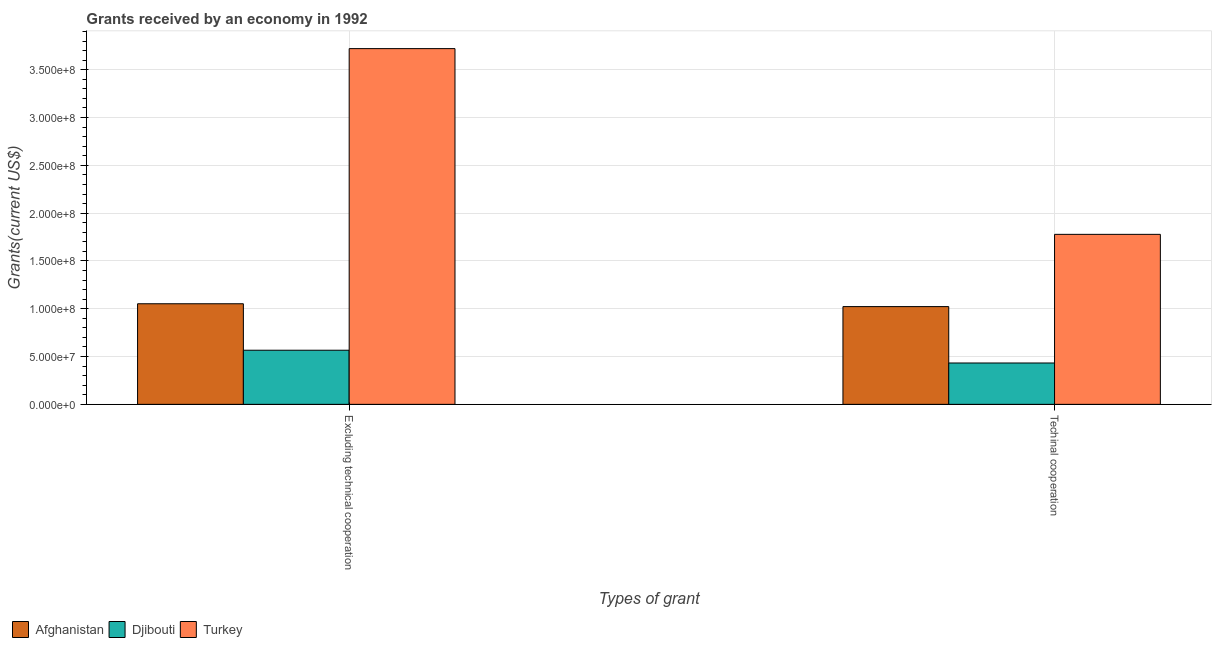How many different coloured bars are there?
Keep it short and to the point. 3. Are the number of bars on each tick of the X-axis equal?
Make the answer very short. Yes. How many bars are there on the 1st tick from the right?
Your answer should be compact. 3. What is the label of the 1st group of bars from the left?
Provide a succinct answer. Excluding technical cooperation. What is the amount of grants received(excluding technical cooperation) in Djibouti?
Your response must be concise. 5.66e+07. Across all countries, what is the maximum amount of grants received(excluding technical cooperation)?
Your answer should be compact. 3.72e+08. Across all countries, what is the minimum amount of grants received(excluding technical cooperation)?
Make the answer very short. 5.66e+07. In which country was the amount of grants received(excluding technical cooperation) minimum?
Make the answer very short. Djibouti. What is the total amount of grants received(including technical cooperation) in the graph?
Ensure brevity in your answer.  3.23e+08. What is the difference between the amount of grants received(including technical cooperation) in Turkey and that in Afghanistan?
Your answer should be compact. 7.56e+07. What is the difference between the amount of grants received(excluding technical cooperation) in Turkey and the amount of grants received(including technical cooperation) in Afghanistan?
Ensure brevity in your answer.  2.70e+08. What is the average amount of grants received(including technical cooperation) per country?
Offer a very short reply. 1.08e+08. What is the difference between the amount of grants received(excluding technical cooperation) and amount of grants received(including technical cooperation) in Turkey?
Keep it short and to the point. 1.94e+08. In how many countries, is the amount of grants received(including technical cooperation) greater than 200000000 US$?
Provide a succinct answer. 0. What is the ratio of the amount of grants received(excluding technical cooperation) in Djibouti to that in Afghanistan?
Offer a very short reply. 0.54. Is the amount of grants received(excluding technical cooperation) in Turkey less than that in Djibouti?
Provide a short and direct response. No. In how many countries, is the amount of grants received(including technical cooperation) greater than the average amount of grants received(including technical cooperation) taken over all countries?
Provide a short and direct response. 1. What does the 1st bar from the left in Excluding technical cooperation represents?
Offer a terse response. Afghanistan. Are all the bars in the graph horizontal?
Offer a very short reply. No. How are the legend labels stacked?
Provide a short and direct response. Horizontal. What is the title of the graph?
Offer a terse response. Grants received by an economy in 1992. Does "Fragile and conflict affected situations" appear as one of the legend labels in the graph?
Your answer should be compact. No. What is the label or title of the X-axis?
Give a very brief answer. Types of grant. What is the label or title of the Y-axis?
Ensure brevity in your answer.  Grants(current US$). What is the Grants(current US$) of Afghanistan in Excluding technical cooperation?
Your answer should be very brief. 1.05e+08. What is the Grants(current US$) of Djibouti in Excluding technical cooperation?
Ensure brevity in your answer.  5.66e+07. What is the Grants(current US$) of Turkey in Excluding technical cooperation?
Give a very brief answer. 3.72e+08. What is the Grants(current US$) in Afghanistan in Techinal cooperation?
Make the answer very short. 1.02e+08. What is the Grants(current US$) of Djibouti in Techinal cooperation?
Offer a terse response. 4.33e+07. What is the Grants(current US$) in Turkey in Techinal cooperation?
Your answer should be very brief. 1.78e+08. Across all Types of grant, what is the maximum Grants(current US$) of Afghanistan?
Keep it short and to the point. 1.05e+08. Across all Types of grant, what is the maximum Grants(current US$) of Djibouti?
Offer a terse response. 5.66e+07. Across all Types of grant, what is the maximum Grants(current US$) of Turkey?
Give a very brief answer. 3.72e+08. Across all Types of grant, what is the minimum Grants(current US$) in Afghanistan?
Give a very brief answer. 1.02e+08. Across all Types of grant, what is the minimum Grants(current US$) in Djibouti?
Your response must be concise. 4.33e+07. Across all Types of grant, what is the minimum Grants(current US$) in Turkey?
Give a very brief answer. 1.78e+08. What is the total Grants(current US$) of Afghanistan in the graph?
Offer a very short reply. 2.07e+08. What is the total Grants(current US$) of Djibouti in the graph?
Keep it short and to the point. 9.99e+07. What is the total Grants(current US$) in Turkey in the graph?
Your answer should be compact. 5.50e+08. What is the difference between the Grants(current US$) of Afghanistan in Excluding technical cooperation and that in Techinal cooperation?
Provide a succinct answer. 2.96e+06. What is the difference between the Grants(current US$) of Djibouti in Excluding technical cooperation and that in Techinal cooperation?
Provide a short and direct response. 1.34e+07. What is the difference between the Grants(current US$) in Turkey in Excluding technical cooperation and that in Techinal cooperation?
Your answer should be very brief. 1.94e+08. What is the difference between the Grants(current US$) of Afghanistan in Excluding technical cooperation and the Grants(current US$) of Djibouti in Techinal cooperation?
Make the answer very short. 6.19e+07. What is the difference between the Grants(current US$) of Afghanistan in Excluding technical cooperation and the Grants(current US$) of Turkey in Techinal cooperation?
Your response must be concise. -7.26e+07. What is the difference between the Grants(current US$) in Djibouti in Excluding technical cooperation and the Grants(current US$) in Turkey in Techinal cooperation?
Your answer should be compact. -1.21e+08. What is the average Grants(current US$) in Afghanistan per Types of grant?
Your response must be concise. 1.04e+08. What is the average Grants(current US$) of Djibouti per Types of grant?
Provide a succinct answer. 4.99e+07. What is the average Grants(current US$) in Turkey per Types of grant?
Offer a very short reply. 2.75e+08. What is the difference between the Grants(current US$) in Afghanistan and Grants(current US$) in Djibouti in Excluding technical cooperation?
Give a very brief answer. 4.86e+07. What is the difference between the Grants(current US$) in Afghanistan and Grants(current US$) in Turkey in Excluding technical cooperation?
Your answer should be compact. -2.67e+08. What is the difference between the Grants(current US$) in Djibouti and Grants(current US$) in Turkey in Excluding technical cooperation?
Make the answer very short. -3.15e+08. What is the difference between the Grants(current US$) in Afghanistan and Grants(current US$) in Djibouti in Techinal cooperation?
Provide a short and direct response. 5.90e+07. What is the difference between the Grants(current US$) in Afghanistan and Grants(current US$) in Turkey in Techinal cooperation?
Give a very brief answer. -7.56e+07. What is the difference between the Grants(current US$) in Djibouti and Grants(current US$) in Turkey in Techinal cooperation?
Provide a short and direct response. -1.35e+08. What is the ratio of the Grants(current US$) of Afghanistan in Excluding technical cooperation to that in Techinal cooperation?
Give a very brief answer. 1.03. What is the ratio of the Grants(current US$) of Djibouti in Excluding technical cooperation to that in Techinal cooperation?
Ensure brevity in your answer.  1.31. What is the ratio of the Grants(current US$) in Turkey in Excluding technical cooperation to that in Techinal cooperation?
Make the answer very short. 2.09. What is the difference between the highest and the second highest Grants(current US$) of Afghanistan?
Make the answer very short. 2.96e+06. What is the difference between the highest and the second highest Grants(current US$) in Djibouti?
Your answer should be compact. 1.34e+07. What is the difference between the highest and the second highest Grants(current US$) in Turkey?
Your response must be concise. 1.94e+08. What is the difference between the highest and the lowest Grants(current US$) of Afghanistan?
Ensure brevity in your answer.  2.96e+06. What is the difference between the highest and the lowest Grants(current US$) in Djibouti?
Keep it short and to the point. 1.34e+07. What is the difference between the highest and the lowest Grants(current US$) in Turkey?
Provide a succinct answer. 1.94e+08. 